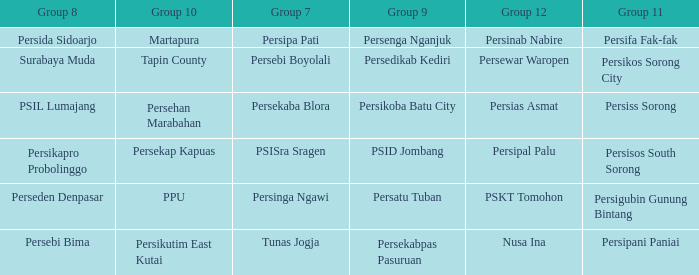Could you parse the entire table as a dict? {'header': ['Group 8', 'Group 10', 'Group 7', 'Group 9', 'Group 12', 'Group 11'], 'rows': [['Persida Sidoarjo', 'Martapura', 'Persipa Pati', 'Persenga Nganjuk', 'Persinab Nabire', 'Persifa Fak-fak'], ['Surabaya Muda', 'Tapin County', 'Persebi Boyolali', 'Persedikab Kediri', 'Persewar Waropen', 'Persikos Sorong City'], ['PSIL Lumajang', 'Persehan Marabahan', 'Persekaba Blora', 'Persikoba Batu City', 'Persias Asmat', 'Persiss Sorong'], ['Persikapro Probolinggo', 'Persekap Kapuas', 'PSISra Sragen', 'PSID Jombang', 'Persipal Palu', 'Persisos South Sorong'], ['Perseden Denpasar', 'PPU', 'Persinga Ngawi', 'Persatu Tuban', 'PSKT Tomohon', 'Persigubin Gunung Bintang'], ['Persebi Bima', 'Persikutim East Kutai', 'Tunas Jogja', 'Persekabpas Pasuruan', 'Nusa Ina', 'Persipani Paniai']]} Who played in group 11 when Persipal Palu played in group 12? Persisos South Sorong. 